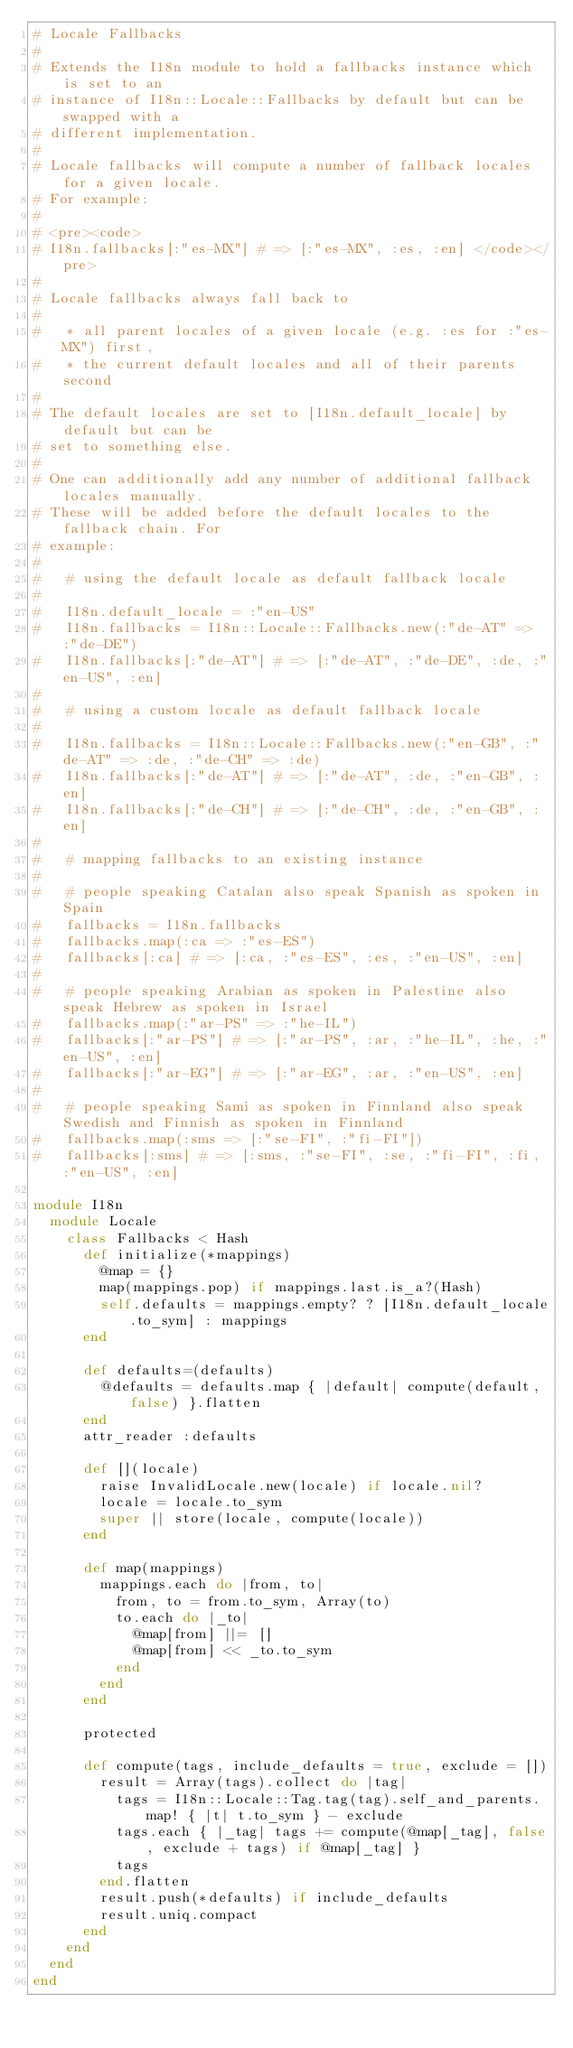<code> <loc_0><loc_0><loc_500><loc_500><_Ruby_># Locale Fallbacks
#
# Extends the I18n module to hold a fallbacks instance which is set to an
# instance of I18n::Locale::Fallbacks by default but can be swapped with a
# different implementation.
#
# Locale fallbacks will compute a number of fallback locales for a given locale.
# For example:
#
# <pre><code>
# I18n.fallbacks[:"es-MX"] # => [:"es-MX", :es, :en] </code></pre>
#
# Locale fallbacks always fall back to
#
#   * all parent locales of a given locale (e.g. :es for :"es-MX") first,
#   * the current default locales and all of their parents second
#
# The default locales are set to [I18n.default_locale] by default but can be
# set to something else.
#
# One can additionally add any number of additional fallback locales manually.
# These will be added before the default locales to the fallback chain. For
# example:
#
#   # using the default locale as default fallback locale
#
#   I18n.default_locale = :"en-US"
#   I18n.fallbacks = I18n::Locale::Fallbacks.new(:"de-AT" => :"de-DE")
#   I18n.fallbacks[:"de-AT"] # => [:"de-AT", :"de-DE", :de, :"en-US", :en]
#
#   # using a custom locale as default fallback locale
#
#   I18n.fallbacks = I18n::Locale::Fallbacks.new(:"en-GB", :"de-AT" => :de, :"de-CH" => :de)
#   I18n.fallbacks[:"de-AT"] # => [:"de-AT", :de, :"en-GB", :en]
#   I18n.fallbacks[:"de-CH"] # => [:"de-CH", :de, :"en-GB", :en]
#
#   # mapping fallbacks to an existing instance
#
#   # people speaking Catalan also speak Spanish as spoken in Spain
#   fallbacks = I18n.fallbacks
#   fallbacks.map(:ca => :"es-ES")
#   fallbacks[:ca] # => [:ca, :"es-ES", :es, :"en-US", :en]
#
#   # people speaking Arabian as spoken in Palestine also speak Hebrew as spoken in Israel
#   fallbacks.map(:"ar-PS" => :"he-IL")
#   fallbacks[:"ar-PS"] # => [:"ar-PS", :ar, :"he-IL", :he, :"en-US", :en]
#   fallbacks[:"ar-EG"] # => [:"ar-EG", :ar, :"en-US", :en]
#
#   # people speaking Sami as spoken in Finnland also speak Swedish and Finnish as spoken in Finnland
#   fallbacks.map(:sms => [:"se-FI", :"fi-FI"])
#   fallbacks[:sms] # => [:sms, :"se-FI", :se, :"fi-FI", :fi, :"en-US", :en]

module I18n
  module Locale
    class Fallbacks < Hash
      def initialize(*mappings)
        @map = {}
        map(mappings.pop) if mappings.last.is_a?(Hash)
        self.defaults = mappings.empty? ? [I18n.default_locale.to_sym] : mappings
      end

      def defaults=(defaults)
        @defaults = defaults.map { |default| compute(default, false) }.flatten
      end
      attr_reader :defaults

      def [](locale)
        raise InvalidLocale.new(locale) if locale.nil?
        locale = locale.to_sym
        super || store(locale, compute(locale))
      end

      def map(mappings)
        mappings.each do |from, to|
          from, to = from.to_sym, Array(to)
          to.each do |_to|
            @map[from] ||= []
            @map[from] << _to.to_sym
          end
        end
      end

      protected

      def compute(tags, include_defaults = true, exclude = [])
        result = Array(tags).collect do |tag|
          tags = I18n::Locale::Tag.tag(tag).self_and_parents.map! { |t| t.to_sym } - exclude
          tags.each { |_tag| tags += compute(@map[_tag], false, exclude + tags) if @map[_tag] }
          tags
        end.flatten
        result.push(*defaults) if include_defaults
        result.uniq.compact
      end
    end
  end
end
</code> 